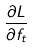<formula> <loc_0><loc_0><loc_500><loc_500>\frac { \partial L } { \partial f _ { t } }</formula> 